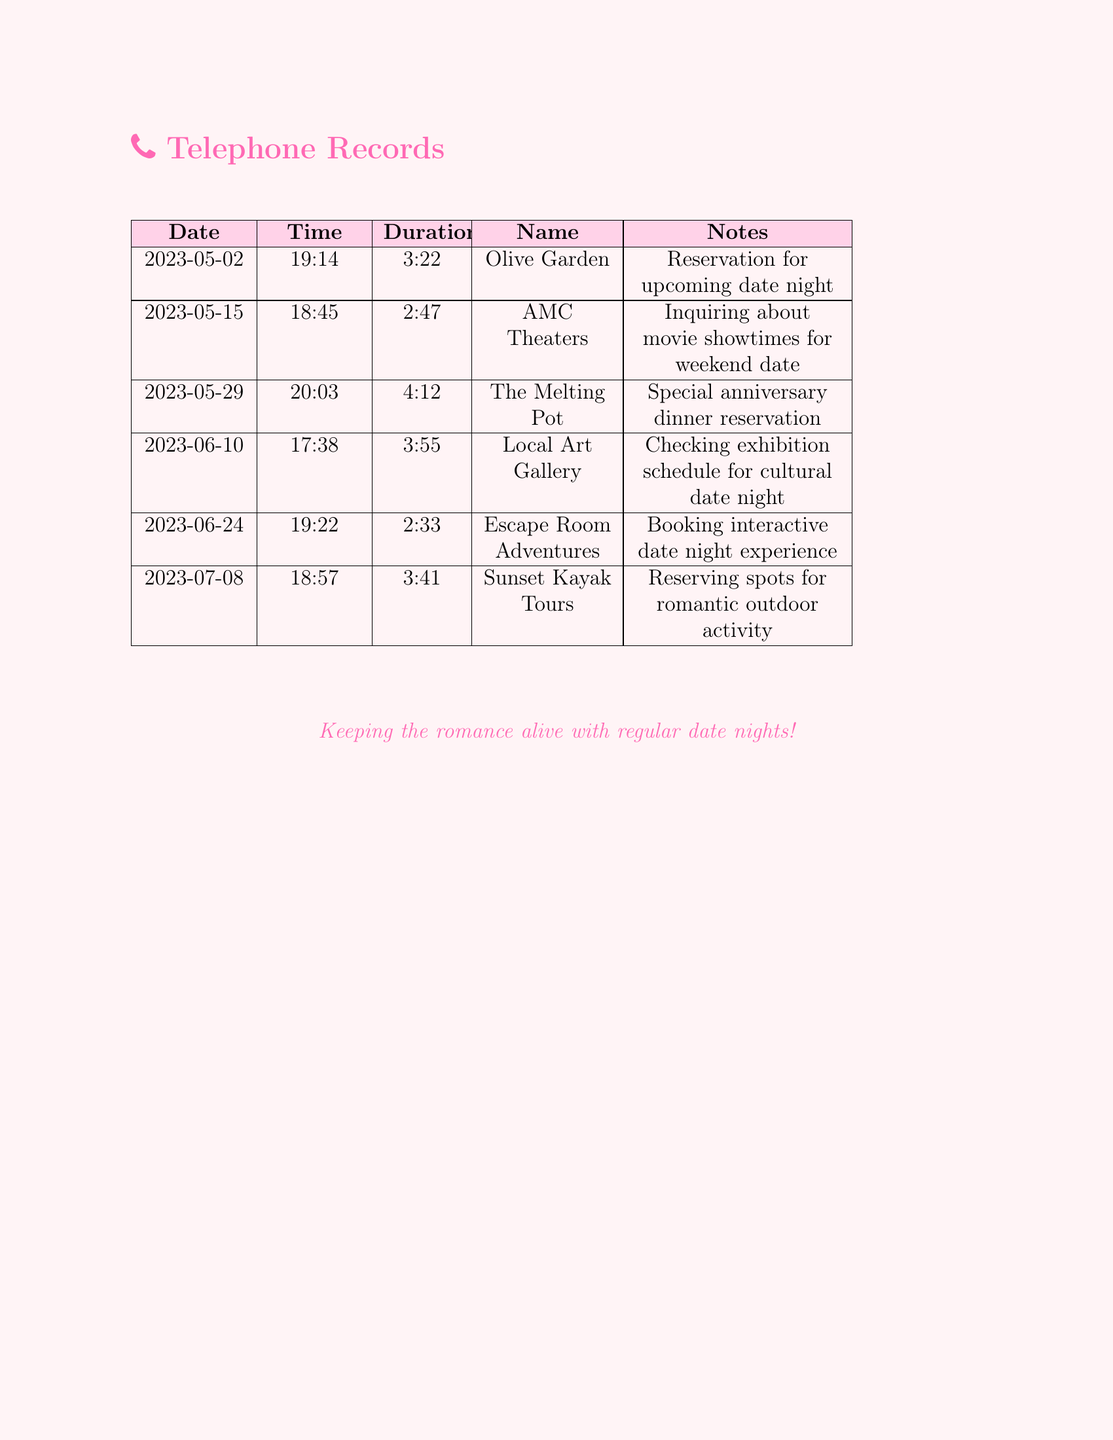What type of restaurant is The Melting Pot? The Melting Pot is mentioned as a venue for a special anniversary dinner reservation, indicating it's a restaurant.
Answer: Restaurant How long was the call to Escape Room Adventures? The duration of the call to Escape Room Adventures is recorded as 2 minutes and 33 seconds.
Answer: 2:33 What activity was booked for July 8? The document reveals that spots were reserved for a romantic outdoor activity with Sunset Kayak Tours.
Answer: Romantic outdoor activity How many calls were made in total? There are six entries listed in the document, indicating the total number of calls made.
Answer: Six What venue was checked for an exhibition schedule? Local Art Gallery was checked for the exhibition schedule in relation to a cultural date night.
Answer: Local Art Gallery What is the overall theme of the telephone records? The records reflect a commitment to keeping the romance alive through regular date nights.
Answer: Keeping the romance alive 